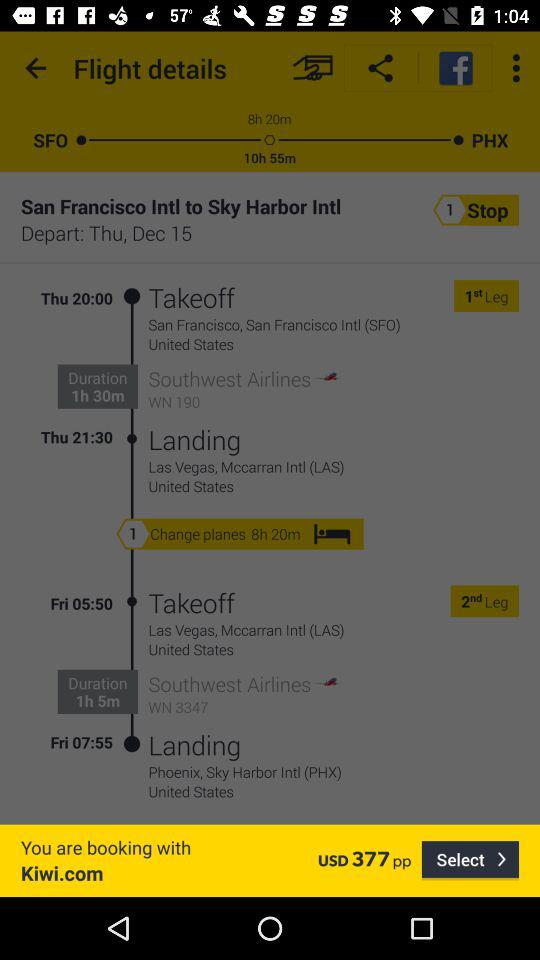What is the landing location of Southwest Airlines WN 190? The landing location of Southwest Airlines WN 190 is Las Vegas, Mccarran Intl (LAS), United States. 